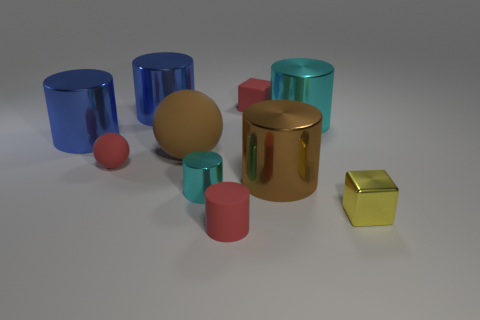What number of things are either matte cylinders or large brown cylinders? In the image, there is a total of one large brown cylinder and two matte cylinders. So, if we count all items that are either matte cylinders or large brown cylinders, we have three in total. 